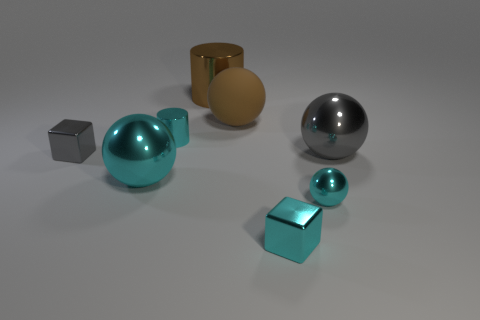Subtract all shiny balls. How many balls are left? 1 Subtract all purple spheres. Subtract all red cylinders. How many spheres are left? 4 Add 1 cyan shiny things. How many objects exist? 9 Subtract all cylinders. How many objects are left? 6 Add 3 brown cylinders. How many brown cylinders exist? 4 Subtract 0 yellow cubes. How many objects are left? 8 Subtract all rubber things. Subtract all big gray shiny things. How many objects are left? 6 Add 6 big cyan things. How many big cyan things are left? 7 